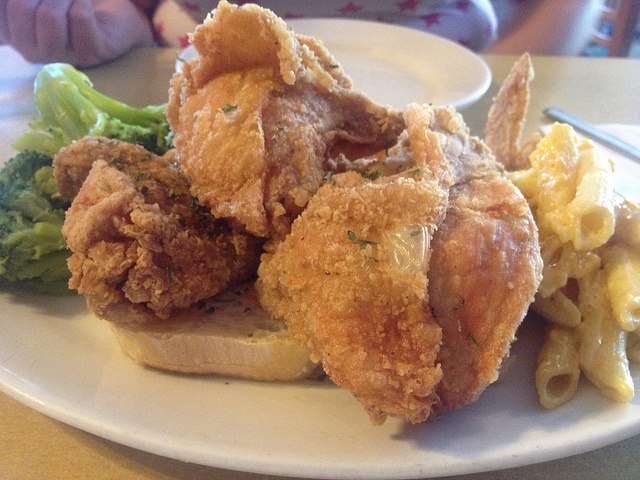Describe the objects in this image and their specific colors. I can see bowl in purple, tan, darkgray, and gray tones, people in purple and gray tones, broccoli in purple, darkgreen, olive, gray, and black tones, and bowl in purple, tan, lightgray, and darkgray tones in this image. 